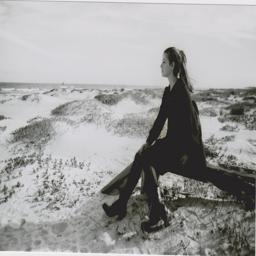What time of day does this image seem to capture? The lighting in the image suggests it is either early morning or late afternoon. The soft, diffuse light and long shadows typically indicate times when the sun is lower in the sky, enhancing the serene ambience of the dune landscape. 